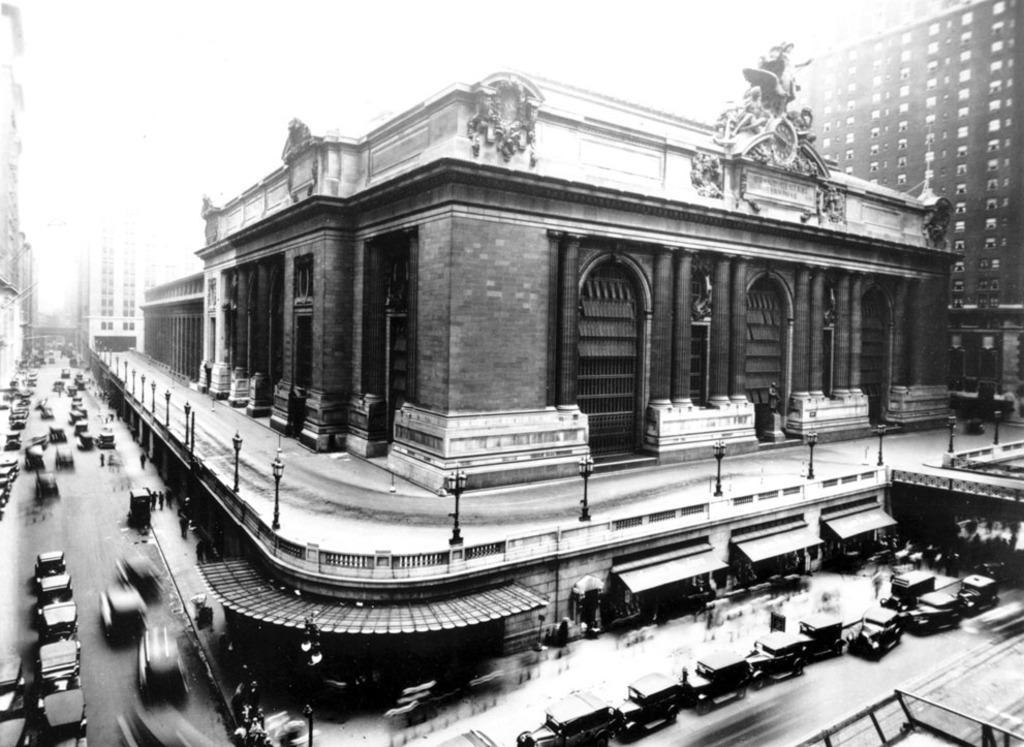Describe this image in one or two sentences. In this image we can see black and white picture of building with doors. In the foreground we can see group of vehicles parked on the road, group of poles. In the background we can see buildings and sky. 